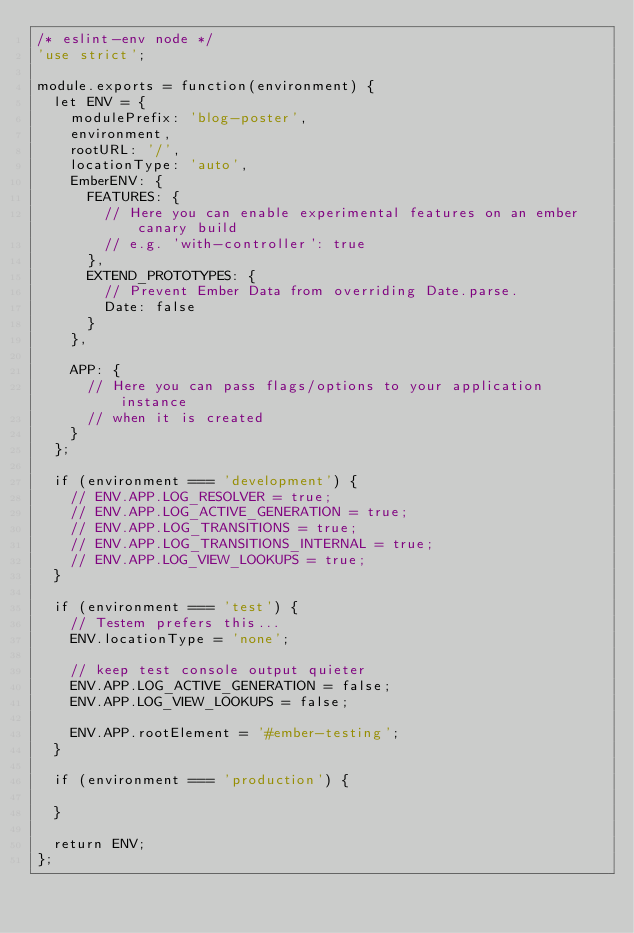Convert code to text. <code><loc_0><loc_0><loc_500><loc_500><_JavaScript_>/* eslint-env node */
'use strict';

module.exports = function(environment) {
  let ENV = {
    modulePrefix: 'blog-poster',
    environment,
    rootURL: '/',
    locationType: 'auto',
    EmberENV: {
      FEATURES: {
        // Here you can enable experimental features on an ember canary build
        // e.g. 'with-controller': true
      },
      EXTEND_PROTOTYPES: {
        // Prevent Ember Data from overriding Date.parse.
        Date: false
      }
    },

    APP: {
      // Here you can pass flags/options to your application instance
      // when it is created
    }
  };

  if (environment === 'development') {
    // ENV.APP.LOG_RESOLVER = true;
    // ENV.APP.LOG_ACTIVE_GENERATION = true;
    // ENV.APP.LOG_TRANSITIONS = true;
    // ENV.APP.LOG_TRANSITIONS_INTERNAL = true;
    // ENV.APP.LOG_VIEW_LOOKUPS = true;
  }

  if (environment === 'test') {
    // Testem prefers this...
    ENV.locationType = 'none';

    // keep test console output quieter
    ENV.APP.LOG_ACTIVE_GENERATION = false;
    ENV.APP.LOG_VIEW_LOOKUPS = false;

    ENV.APP.rootElement = '#ember-testing';
  }

  if (environment === 'production') {

  }

  return ENV;
};
</code> 